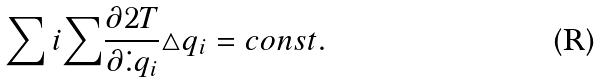<formula> <loc_0><loc_0><loc_500><loc_500>\sum { i } { \sum } \frac { \partial 2 T } { \partial \dot { . } { q } _ { i } } \triangle q _ { i } = c o n s t .</formula> 